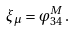Convert formula to latex. <formula><loc_0><loc_0><loc_500><loc_500>\xi _ { \mu } = \varphi ^ { M } _ { 3 4 } \, .</formula> 